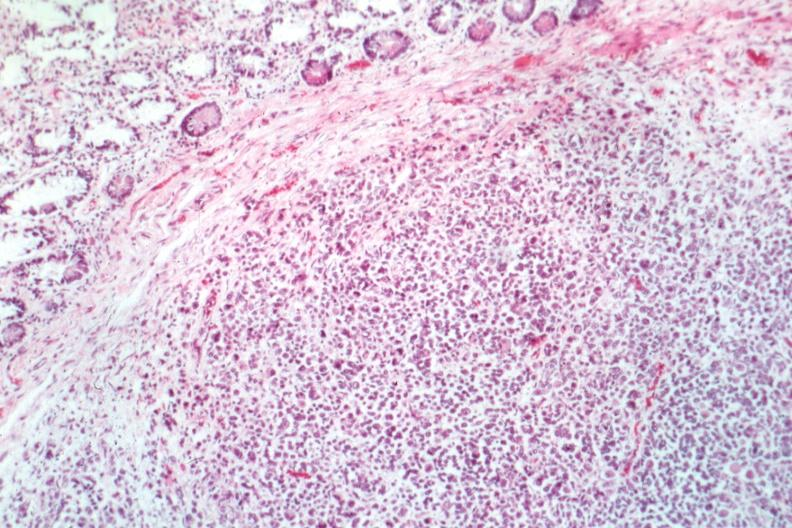s gastrointestinal present?
Answer the question using a single word or phrase. Yes 